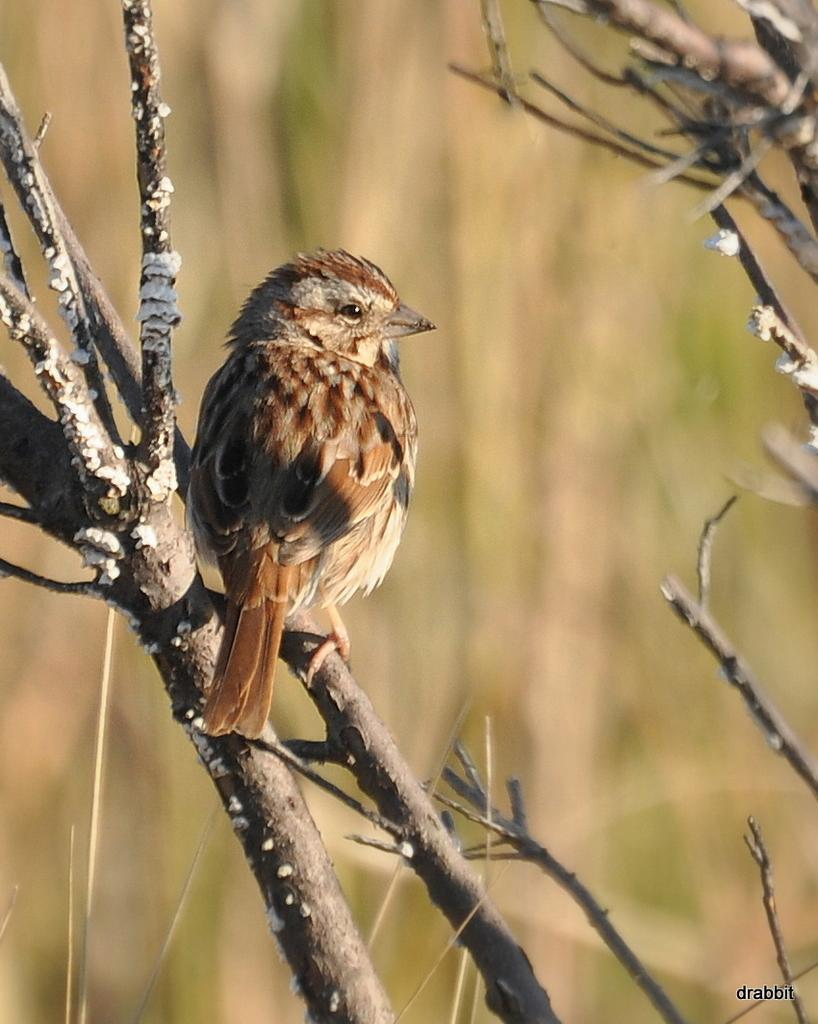What type of animal can be seen in the image? There is a bird in the image. Where is the bird located? The bird is sitting on a tree branch. Can you describe the background of the image? The background of the image is blurred. What type of pest is visible on the bird's feathers in the image? There is no pest visible on the bird's feathers in the image. What color is the sock that the bird is wearing in the image? There is no sock present on the bird in the image. 